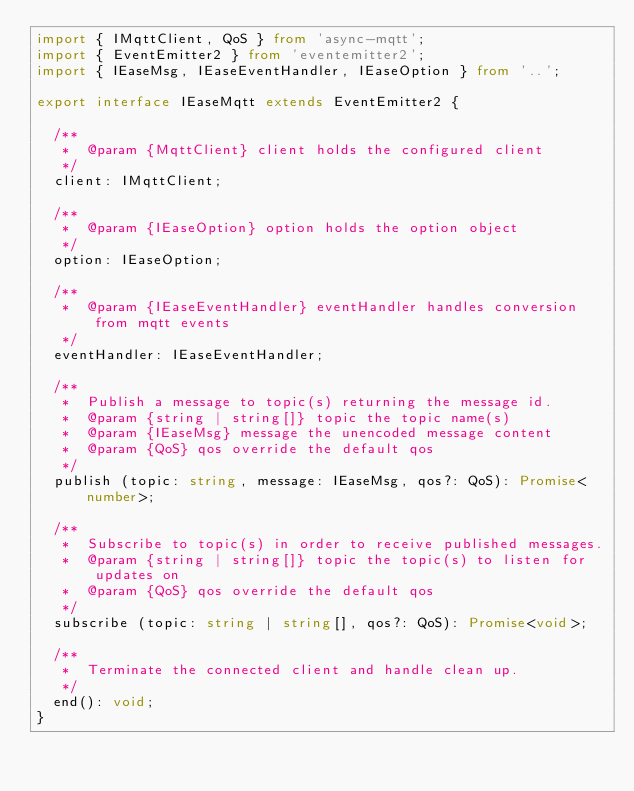Convert code to text. <code><loc_0><loc_0><loc_500><loc_500><_TypeScript_>import { IMqttClient, QoS } from 'async-mqtt';
import { EventEmitter2 } from 'eventemitter2';
import { IEaseMsg, IEaseEventHandler, IEaseOption } from '..';

export interface IEaseMqtt extends EventEmitter2 {

  /**
   *  @param {MqttClient} client holds the configured client
   */
  client: IMqttClient;

  /**
   *  @param {IEaseOption} option holds the option object
   */
  option: IEaseOption;

  /**
   *  @param {IEaseEventHandler} eventHandler handles conversion from mqtt events
   */
  eventHandler: IEaseEventHandler;

  /**
   *  Publish a message to topic(s) returning the message id.
   *  @param {string | string[]} topic the topic name(s)
   *  @param {IEaseMsg} message the unencoded message content
   *  @param {QoS} qos override the default qos
   */
  publish (topic: string, message: IEaseMsg, qos?: QoS): Promise<number>;

  /**
   *  Subscribe to topic(s) in order to receive published messages.
   *  @param {string | string[]} topic the topic(s) to listen for updates on
   *  @param {QoS} qos override the default qos
   */
  subscribe (topic: string | string[], qos?: QoS): Promise<void>;

  /**
   *  Terminate the connected client and handle clean up.
   */
  end(): void;
}
</code> 